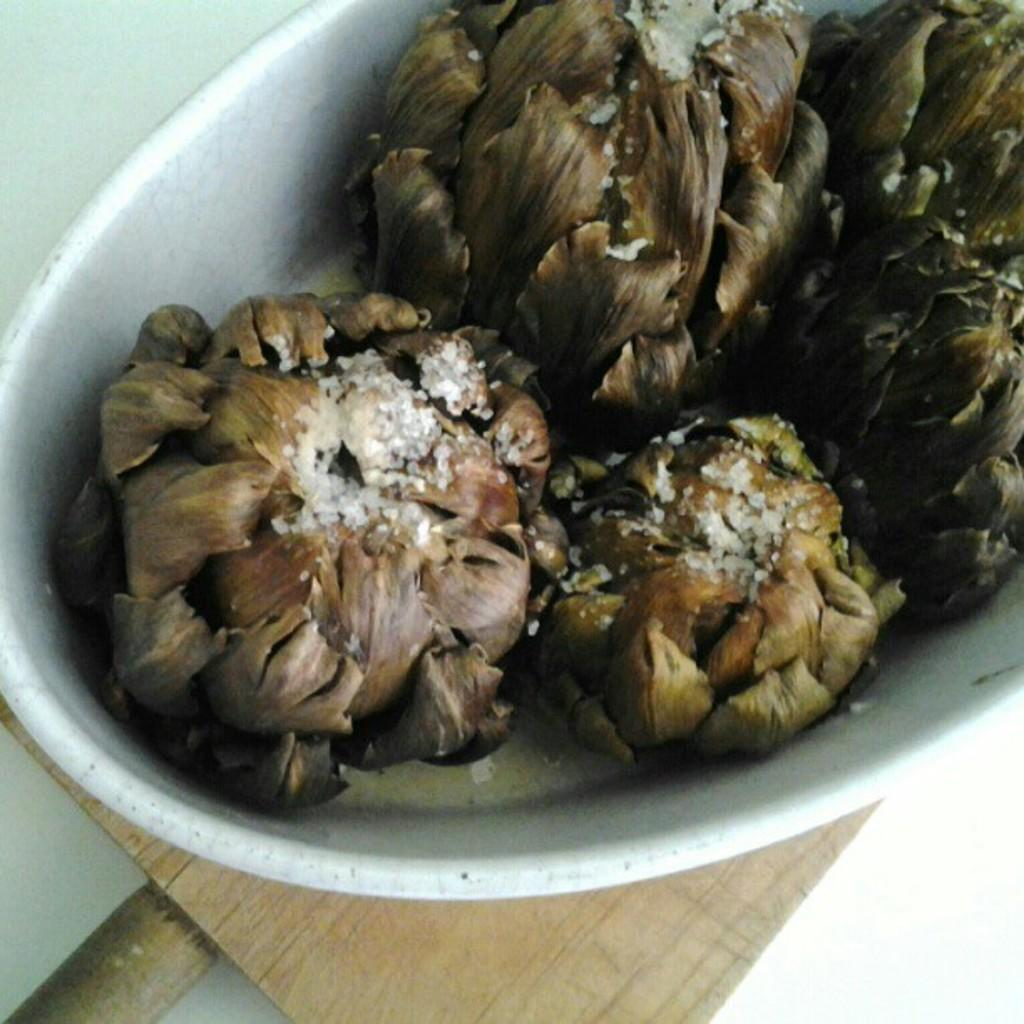What type of food items are present in the image? There are fruits in the image. How are the fruits arranged or contained in the image? The fruits are placed in a white-colored basket. Where is the basket with fruits located in the image? The basket is placed on a table. What is the color of the table in the image? The table is in brown color. What type of rhythm can be heard from the fruits in the image? There is: There is no rhythm associated with the fruits in the image, as they are stationary and not producing any sound. 